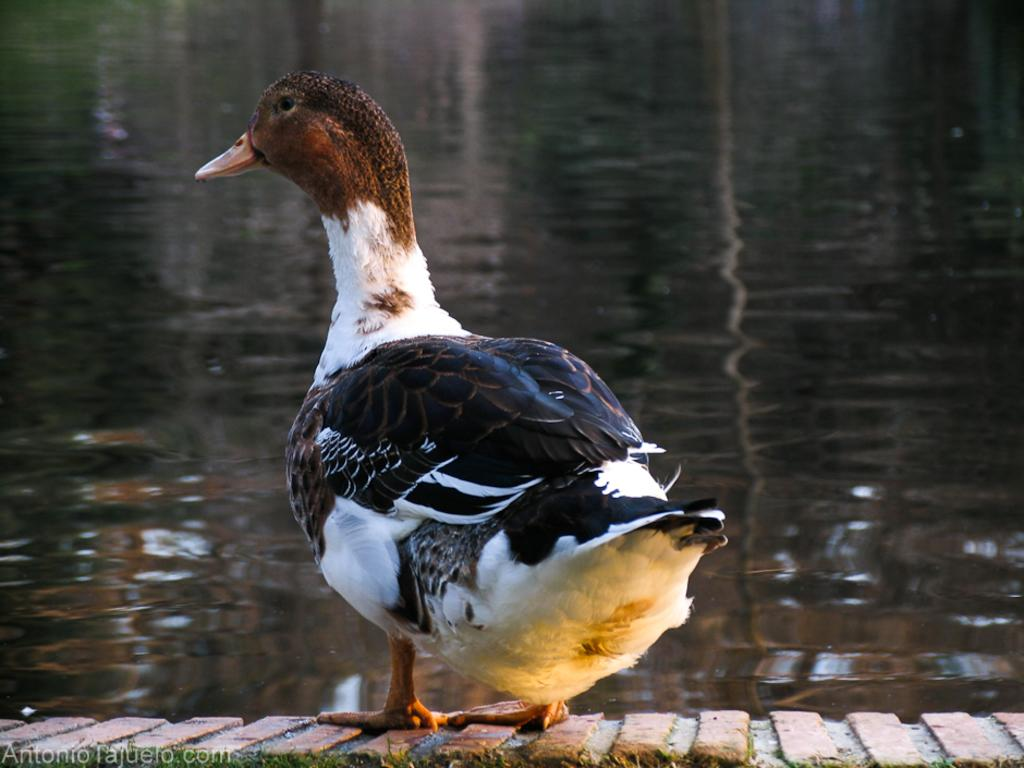What animal is present in the image? There is a duck in the image. Where is the duck located? The duck is on a surface that resembles a wall. What can be seen in the background of the image? There is water visible in the image. How many babies are playing with the net in the image? There is no net or babies present in the image; it features a duck on a surface with water visible in the background. 